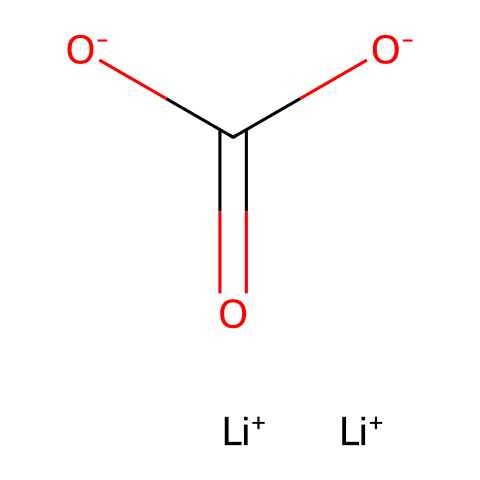What is the total number of lithium ions in this molecule? The SMILES representation shows two instances of lithium (Li) indicated by [Li+]. Therefore, there are two lithium atoms present in the molecule.
Answer: two How many oxygen atoms are present in lithium carbonate? The SMILES structure includes three instances of oxygen: one in the format [O-] and two in the format O, which correspond to the carbonate ion (C(=O)([O-])[O-]). Therefore, there are a total of three oxygen atoms.
Answer: three What type of structure does lithium carbonate represent? Lithium carbonate has a crystalline structure due to the arrangement of its ionic components, which includes lithium ions and carbonate ions held together by ionic bonds.
Answer: crystalline What is the role of carbonate in the structure of lithium carbonate? The carbonate functional group (seen as (C(=O)([O-])[O-])) provides the necessary structure for the ionic bond formation with lithium ions, acting as the anionic part of the electrolyte.
Answer: ionic bond How many total carbon atoms are there in lithium carbonate? The SMILES indicates the presence of one carbon atom in the carbonate group, as represented by the "C" in the structure. Therefore, there is one carbon atom in lithium carbonate.
Answer: one What are the charges of the lithium ions in lithium carbonate? The lithium ions are indicated by [Li+], which denotes a positive charge. There are two lithium ions, both carrying a +1 charge each.
Answer: +1 